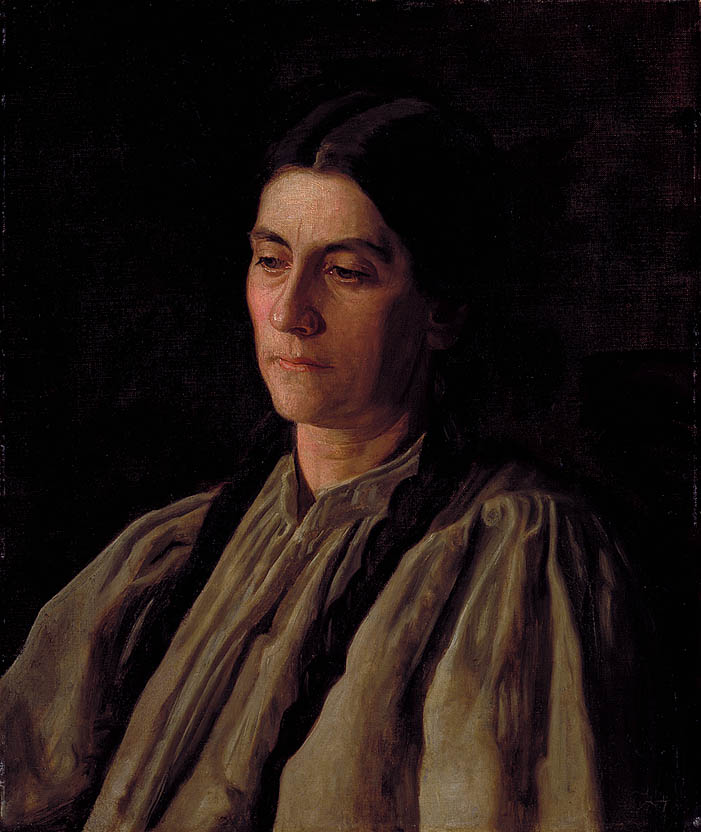What does the choice of clothing reveal about the time period or social status of the woman in the painting? The attire worn by the woman, particularly the high collared blouse and the dark shawl, is indicative of the clothing styles from the late 19th to early 20th century. Her clothes suggest modesty and functionality, which were typical of the middle class during this period. The simplicity and practicality of the attire might imply her role within a conservative societal setting or lesser affluence, which contrasts with the more ornate and elaborate fashion of the upper class of that time. This choice of clothing helps situate her within a specific social and historical context, offering clues about her lifestyle and possibly her values and daily responsibilities. 